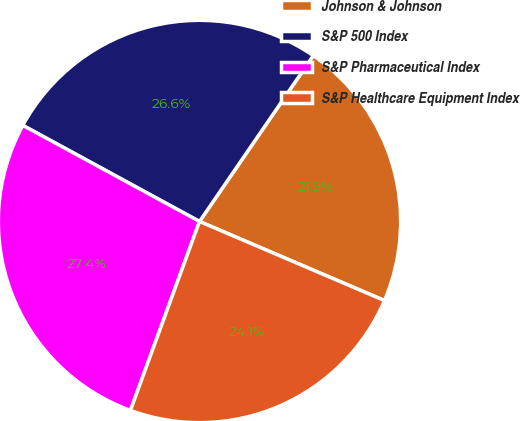Convert chart. <chart><loc_0><loc_0><loc_500><loc_500><pie_chart><fcel>Johnson & Johnson<fcel>S&P 500 Index<fcel>S&P Pharmaceutical Index<fcel>S&P Healthcare Equipment Index<nl><fcel>21.86%<fcel>26.64%<fcel>27.35%<fcel>24.15%<nl></chart> 